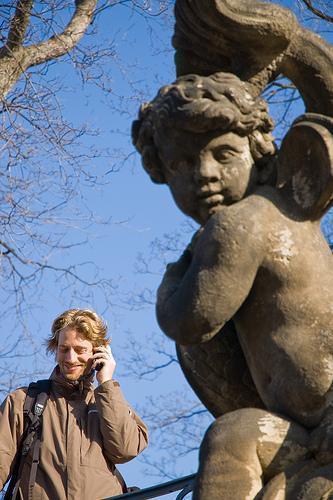How many people are pictured?
Give a very brief answer. 1. 